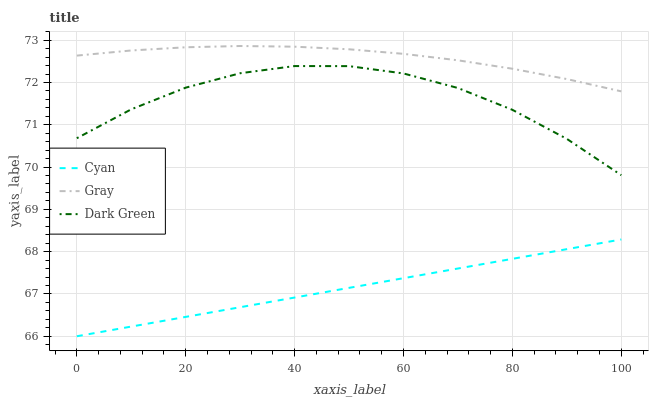Does Dark Green have the minimum area under the curve?
Answer yes or no. No. Does Dark Green have the maximum area under the curve?
Answer yes or no. No. Is Gray the smoothest?
Answer yes or no. No. Is Gray the roughest?
Answer yes or no. No. Does Dark Green have the lowest value?
Answer yes or no. No. Does Dark Green have the highest value?
Answer yes or no. No. Is Cyan less than Gray?
Answer yes or no. Yes. Is Dark Green greater than Cyan?
Answer yes or no. Yes. Does Cyan intersect Gray?
Answer yes or no. No. 